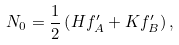<formula> <loc_0><loc_0><loc_500><loc_500>N _ { 0 } = \frac { 1 } { 2 } \left ( H f _ { A } ^ { \prime } + K f _ { B } ^ { \prime } \right ) ,</formula> 